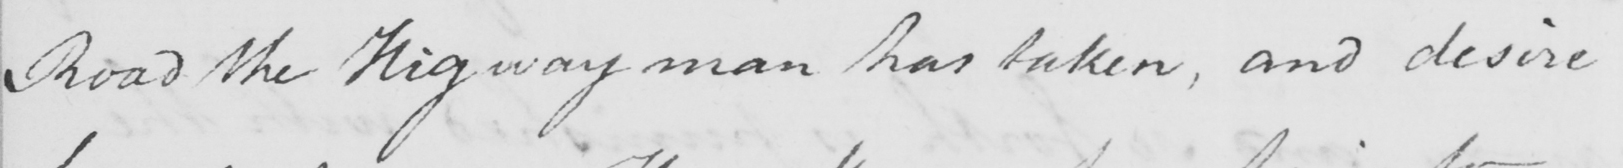Please transcribe the handwritten text in this image. Road the Highway man has taken , and desire 